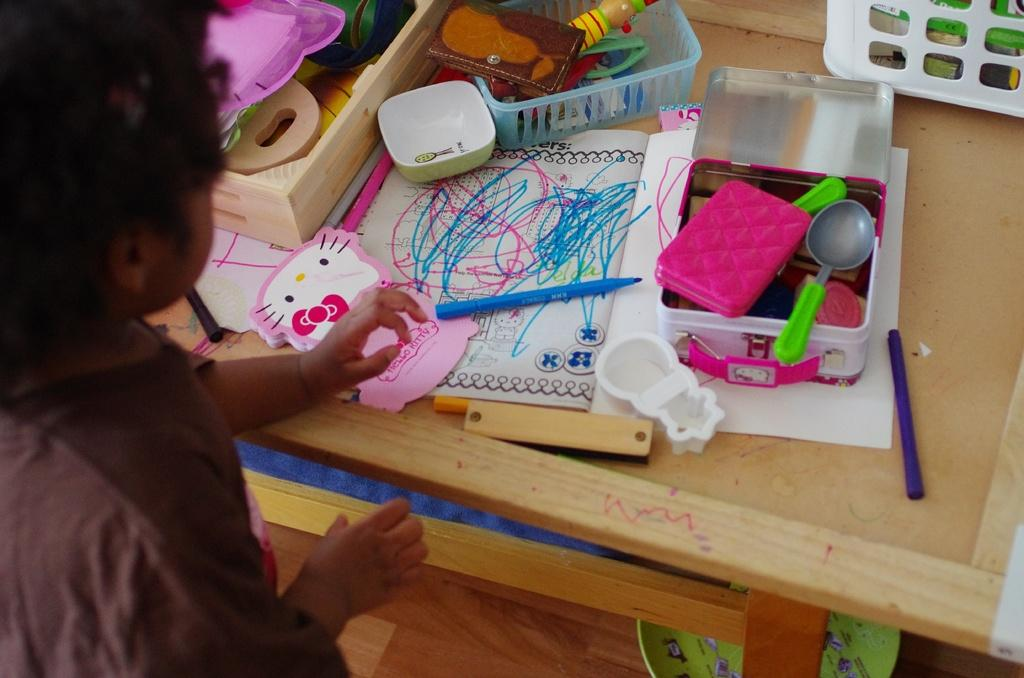What is the main subject of the image? There is a child in the image. What is the child doing in the image? The child is playing with toys. Where are the toys located in the image? The toys are placed on a table. Can you describe some of the toys in the image? Among the toys, there is a spoon, a box, a bowl, a purse, and a watch. Is there anything below the table in the image? Yes, there is a plate below the table. Where is the cave located in the image? There is no cave present in the image. Can you describe the nest among the toys? There is no nest among the toys in the image. 